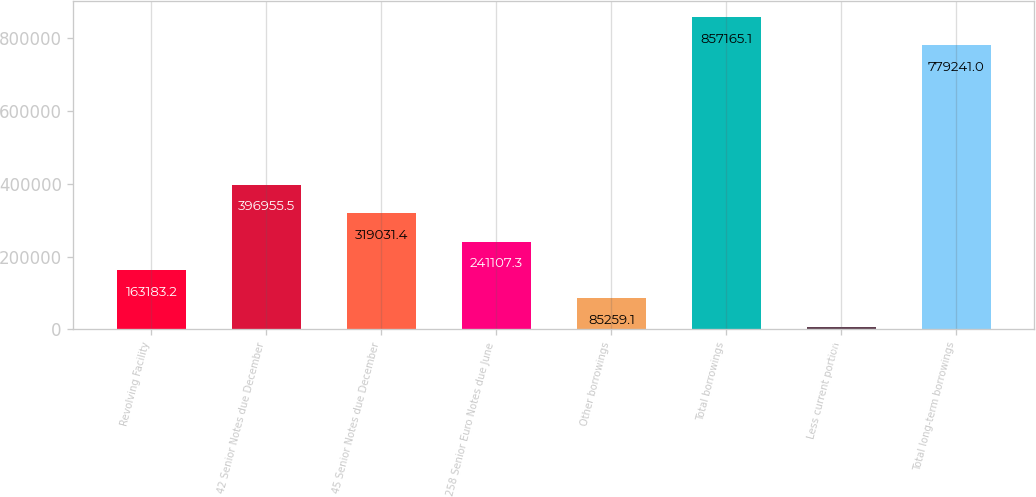<chart> <loc_0><loc_0><loc_500><loc_500><bar_chart><fcel>Revolving Facility<fcel>42 Senior Notes due December<fcel>45 Senior Notes due December<fcel>258 Senior Euro Notes due June<fcel>Other borrowings<fcel>Total borrowings<fcel>Less current portion<fcel>Total long-term borrowings<nl><fcel>163183<fcel>396956<fcel>319031<fcel>241107<fcel>85259.1<fcel>857165<fcel>7335<fcel>779241<nl></chart> 